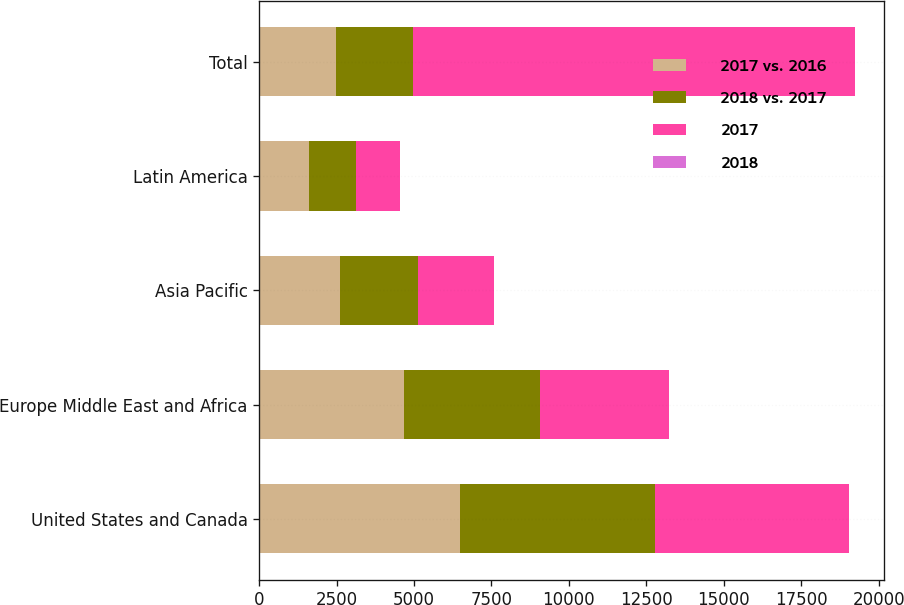Convert chart to OTSL. <chart><loc_0><loc_0><loc_500><loc_500><stacked_bar_chart><ecel><fcel>United States and Canada<fcel>Europe Middle East and Africa<fcel>Asia Pacific<fcel>Latin America<fcel>Total<nl><fcel>2017 vs. 2016<fcel>6485<fcel>4678<fcel>2618<fcel>1593<fcel>2477<nl><fcel>2018 vs. 2017<fcel>6307<fcel>4389<fcel>2523<fcel>1529<fcel>2477<nl><fcel>2017<fcel>6254<fcel>4164<fcel>2431<fcel>1421<fcel>14270<nl><fcel>2018<fcel>2.8<fcel>6.6<fcel>3.8<fcel>4.2<fcel>4.2<nl></chart> 